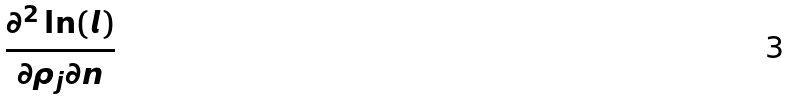<formula> <loc_0><loc_0><loc_500><loc_500>\frac { \partial ^ { 2 } \ln ( l ) } { \partial \rho _ { j } \partial n }</formula> 